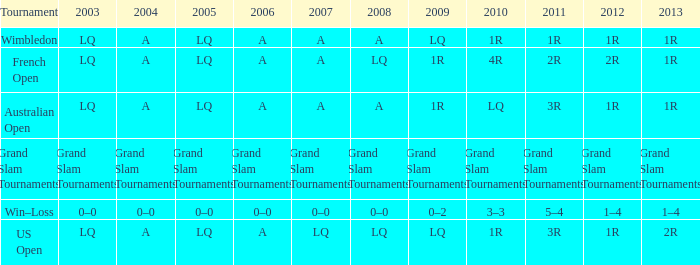Which year has a 2011 of 1r? A. 